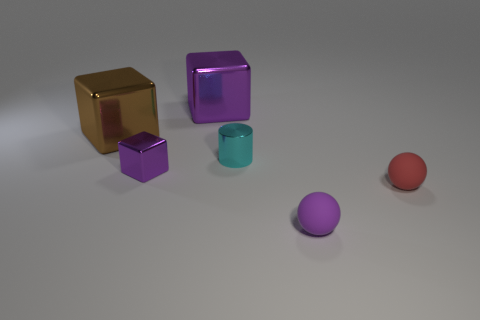Add 3 tiny purple metallic things. How many objects exist? 9 Subtract all balls. How many objects are left? 4 Add 4 red balls. How many red balls exist? 5 Subtract 1 cyan cylinders. How many objects are left? 5 Subtract all brown metallic blocks. Subtract all matte balls. How many objects are left? 3 Add 3 small cyan shiny cylinders. How many small cyan shiny cylinders are left? 4 